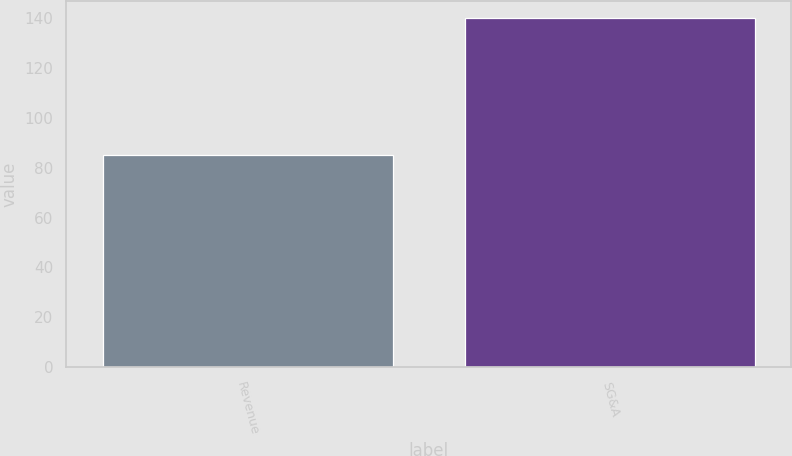<chart> <loc_0><loc_0><loc_500><loc_500><bar_chart><fcel>Revenue<fcel>SG&A<nl><fcel>85<fcel>140<nl></chart> 